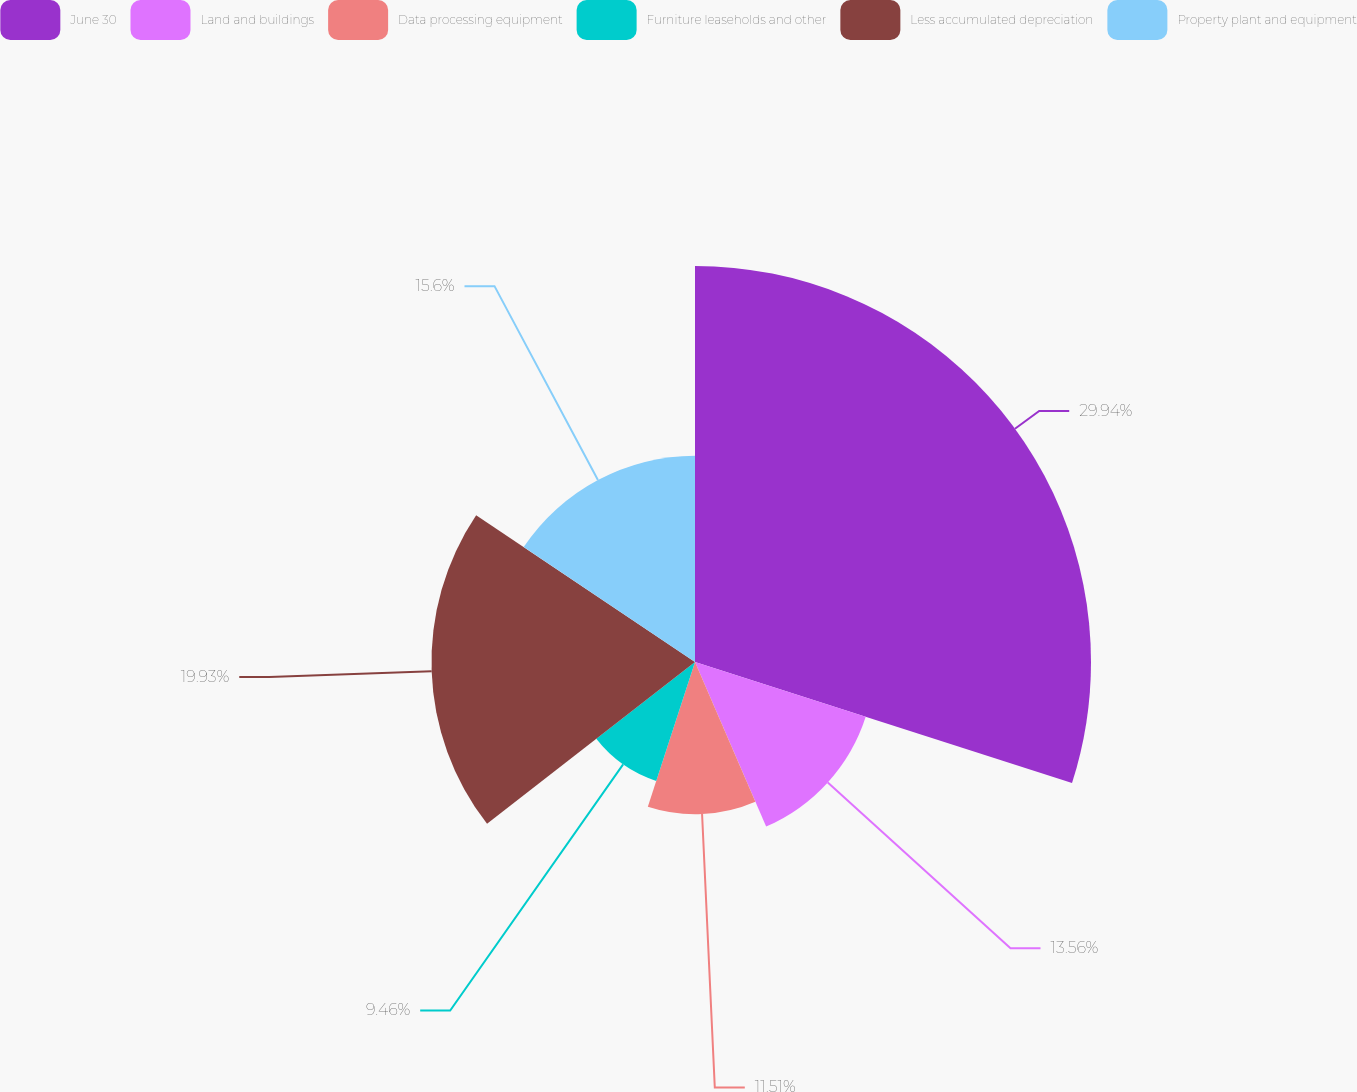Convert chart. <chart><loc_0><loc_0><loc_500><loc_500><pie_chart><fcel>June 30<fcel>Land and buildings<fcel>Data processing equipment<fcel>Furniture leaseholds and other<fcel>Less accumulated depreciation<fcel>Property plant and equipment<nl><fcel>29.95%<fcel>13.56%<fcel>11.51%<fcel>9.46%<fcel>19.93%<fcel>15.6%<nl></chart> 